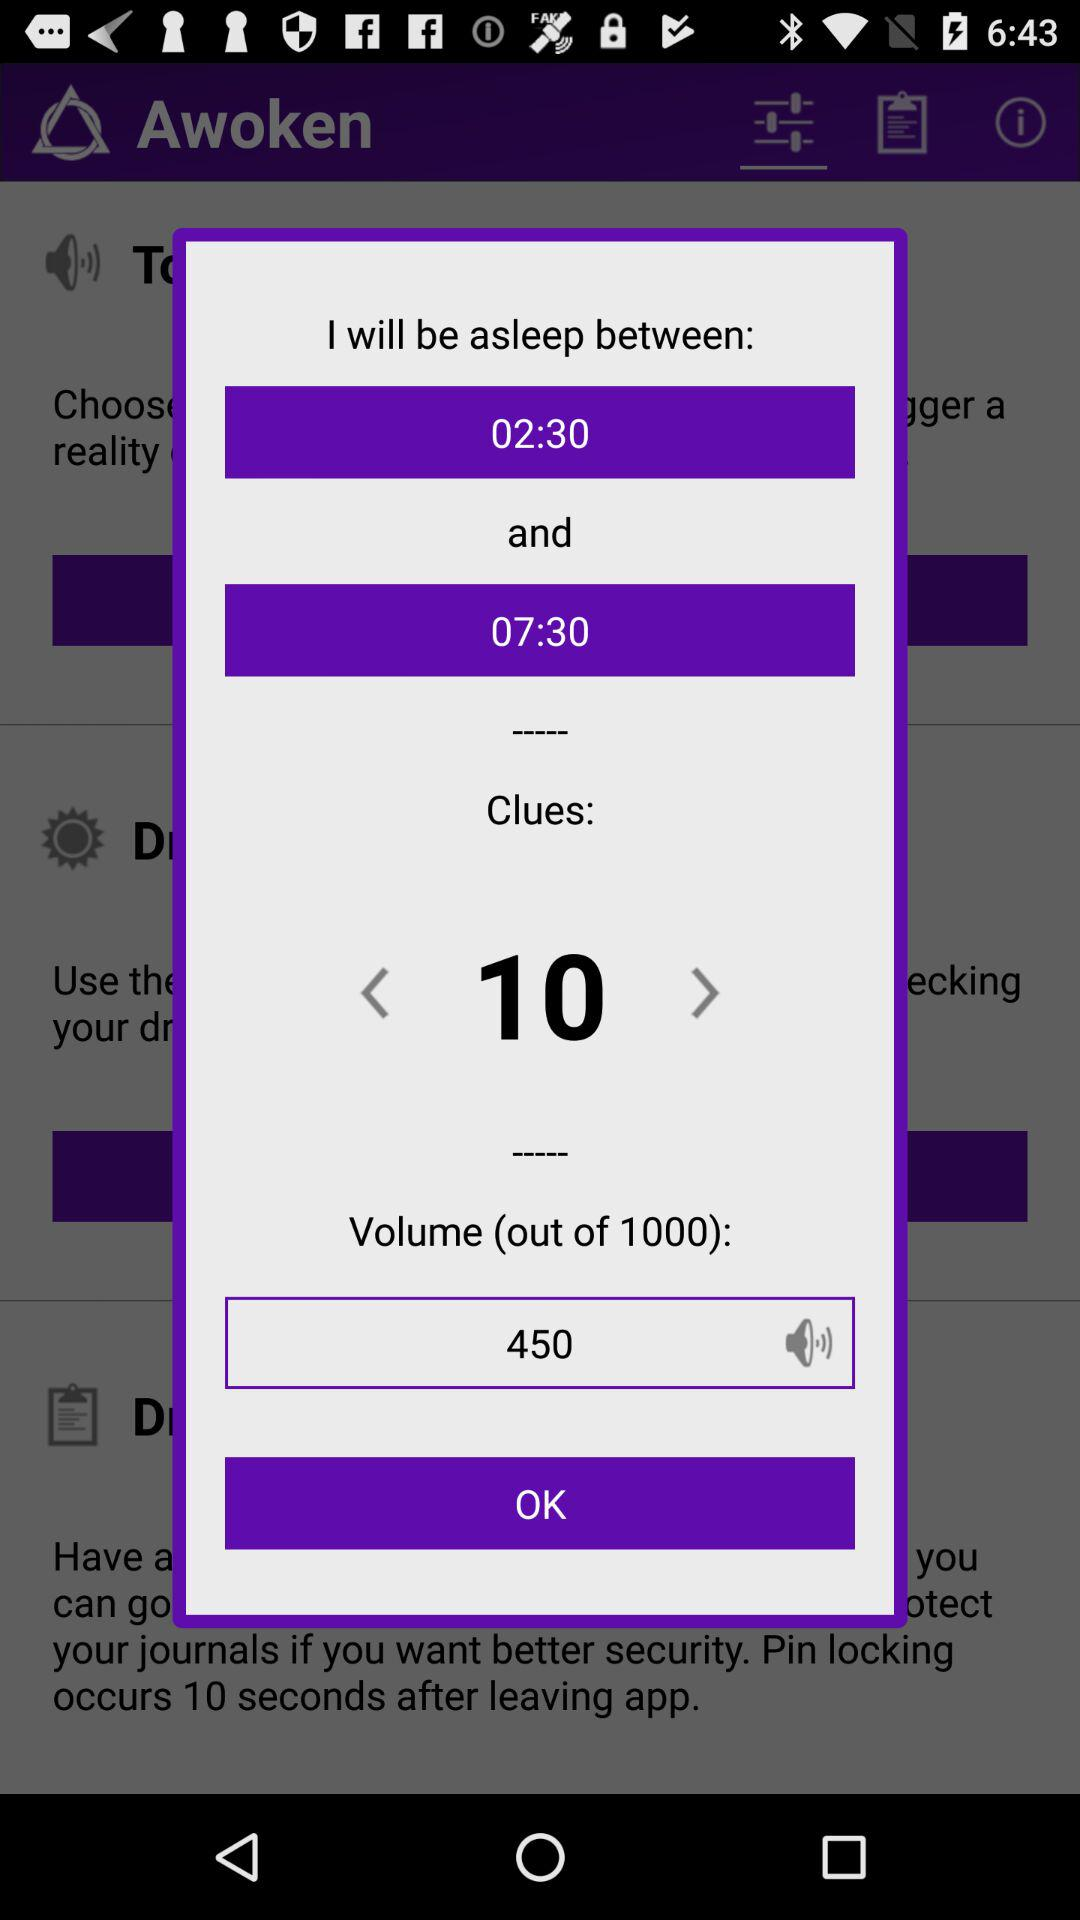What is the value of "Volume (out of 1000)"? The value is 450. 